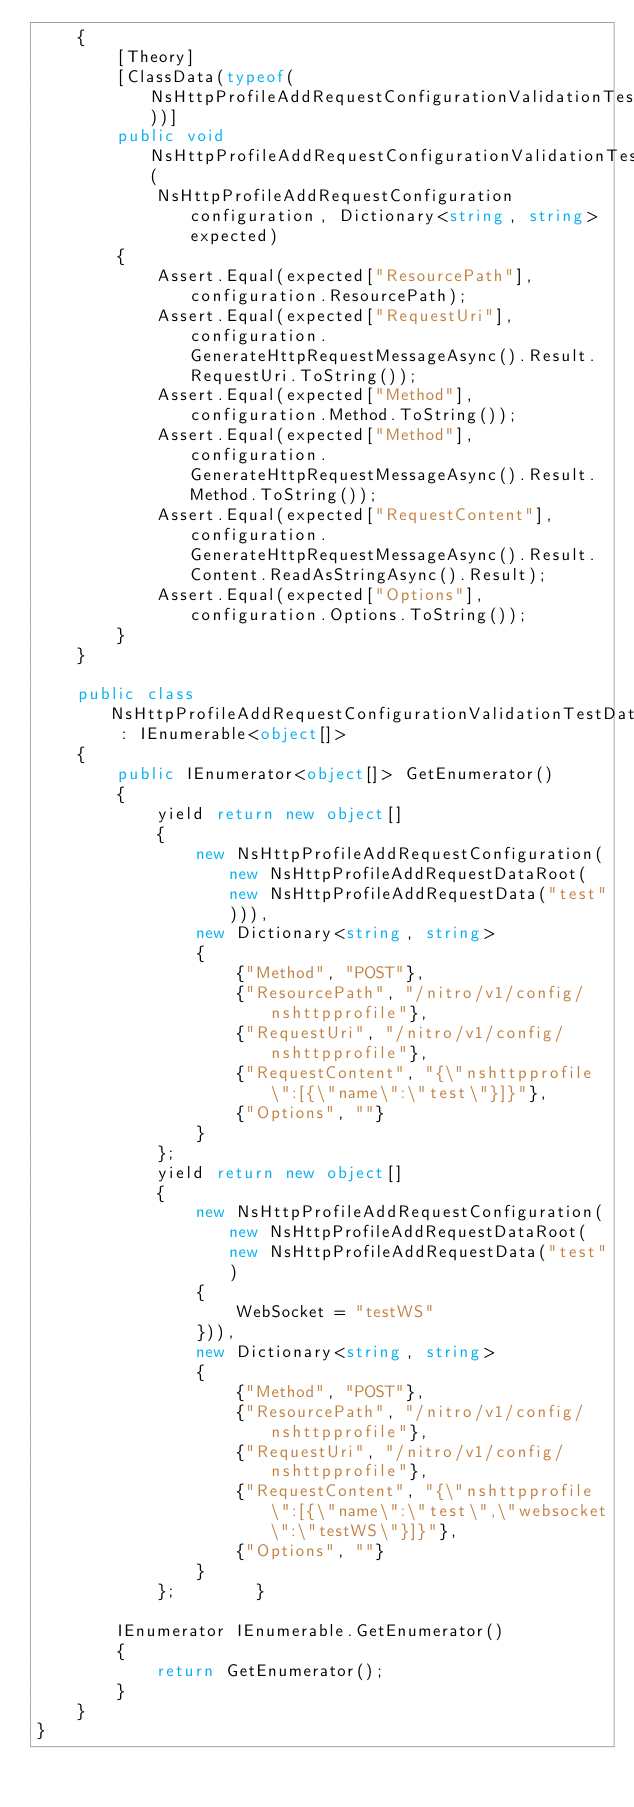Convert code to text. <code><loc_0><loc_0><loc_500><loc_500><_C#_>    {
        [Theory]
        [ClassData(typeof(NsHttpProfileAddRequestConfigurationValidationTestData))]
        public void NsHttpProfileAddRequestConfigurationValidationTest(
            NsHttpProfileAddRequestConfiguration configuration, Dictionary<string, string> expected)
        {
            Assert.Equal(expected["ResourcePath"], configuration.ResourcePath);
            Assert.Equal(expected["RequestUri"], configuration.GenerateHttpRequestMessageAsync().Result.RequestUri.ToString());
            Assert.Equal(expected["Method"], configuration.Method.ToString());
            Assert.Equal(expected["Method"], configuration.GenerateHttpRequestMessageAsync().Result.Method.ToString());
            Assert.Equal(expected["RequestContent"], configuration.GenerateHttpRequestMessageAsync().Result.Content.ReadAsStringAsync().Result);
            Assert.Equal(expected["Options"], configuration.Options.ToString());
        }
    }

    public class NsHttpProfileAddRequestConfigurationValidationTestData : IEnumerable<object[]>
    {
        public IEnumerator<object[]> GetEnumerator()
        {
            yield return new object[]
            {
                new NsHttpProfileAddRequestConfiguration(new NsHttpProfileAddRequestDataRoot(new NsHttpProfileAddRequestData("test"))),
                new Dictionary<string, string>
                {
                    {"Method", "POST"},
                    {"ResourcePath", "/nitro/v1/config/nshttpprofile"},
                    {"RequestUri", "/nitro/v1/config/nshttpprofile"},
                    {"RequestContent", "{\"nshttpprofile\":[{\"name\":\"test\"}]}"},
                    {"Options", ""}
                }
            };
            yield return new object[]
            {
                new NsHttpProfileAddRequestConfiguration(new NsHttpProfileAddRequestDataRoot(new NsHttpProfileAddRequestData("test")
                {
                    WebSocket = "testWS"
                })),
                new Dictionary<string, string>
                {
                    {"Method", "POST"},
                    {"ResourcePath", "/nitro/v1/config/nshttpprofile"},
                    {"RequestUri", "/nitro/v1/config/nshttpprofile"},
                    {"RequestContent", "{\"nshttpprofile\":[{\"name\":\"test\",\"websocket\":\"testWS\"}]}"},
                    {"Options", ""}
                }
            };        }

        IEnumerator IEnumerable.GetEnumerator()
        {
            return GetEnumerator();
        }
    }
}</code> 